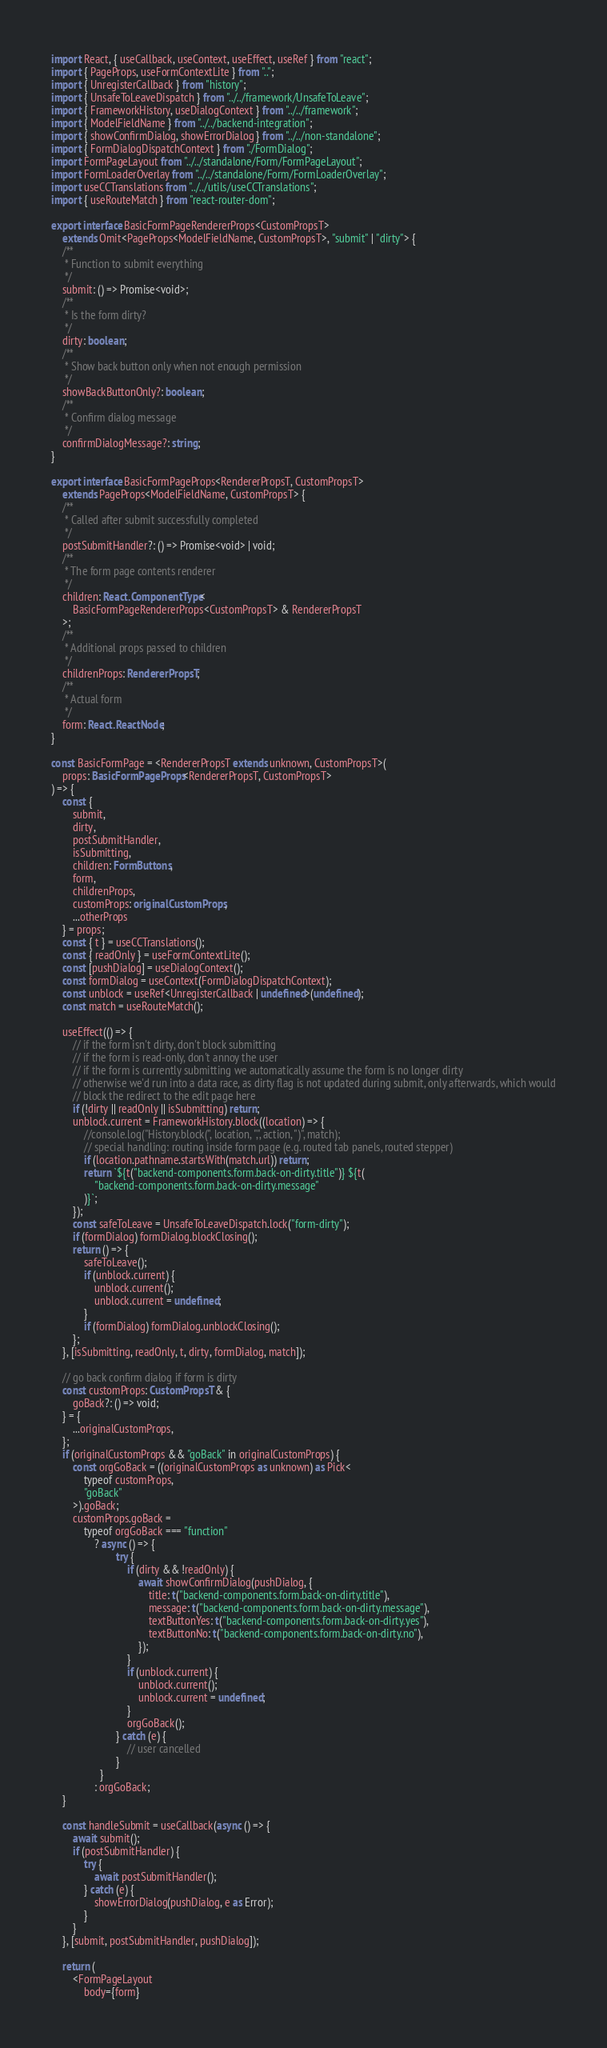<code> <loc_0><loc_0><loc_500><loc_500><_TypeScript_>import React, { useCallback, useContext, useEffect, useRef } from "react";
import { PageProps, useFormContextLite } from "..";
import { UnregisterCallback } from "history";
import { UnsafeToLeaveDispatch } from "../../framework/UnsafeToLeave";
import { FrameworkHistory, useDialogContext } from "../../framework";
import { ModelFieldName } from "../../backend-integration";
import { showConfirmDialog, showErrorDialog } from "../../non-standalone";
import { FormDialogDispatchContext } from "./FormDialog";
import FormPageLayout from "../../standalone/Form/FormPageLayout";
import FormLoaderOverlay from "../../standalone/Form/FormLoaderOverlay";
import useCCTranslations from "../../utils/useCCTranslations";
import { useRouteMatch } from "react-router-dom";

export interface BasicFormPageRendererProps<CustomPropsT>
	extends Omit<PageProps<ModelFieldName, CustomPropsT>, "submit" | "dirty"> {
	/**
	 * Function to submit everything
	 */
	submit: () => Promise<void>;
	/**
	 * Is the form dirty?
	 */
	dirty: boolean;
	/**
	 * Show back button only when not enough permission
	 */
	showBackButtonOnly?: boolean;
	/**
	 * Confirm dialog message
	 */
	confirmDialogMessage?: string;
}

export interface BasicFormPageProps<RendererPropsT, CustomPropsT>
	extends PageProps<ModelFieldName, CustomPropsT> {
	/**
	 * Called after submit successfully completed
	 */
	postSubmitHandler?: () => Promise<void> | void;
	/**
	 * The form page contents renderer
	 */
	children: React.ComponentType<
		BasicFormPageRendererProps<CustomPropsT> & RendererPropsT
	>;
	/**
	 * Additional props passed to children
	 */
	childrenProps: RendererPropsT;
	/**
	 * Actual form
	 */
	form: React.ReactNode;
}

const BasicFormPage = <RendererPropsT extends unknown, CustomPropsT>(
	props: BasicFormPageProps<RendererPropsT, CustomPropsT>
) => {
	const {
		submit,
		dirty,
		postSubmitHandler,
		isSubmitting,
		children: FormButtons,
		form,
		childrenProps,
		customProps: originalCustomProps,
		...otherProps
	} = props;
	const { t } = useCCTranslations();
	const { readOnly } = useFormContextLite();
	const [pushDialog] = useDialogContext();
	const formDialog = useContext(FormDialogDispatchContext);
	const unblock = useRef<UnregisterCallback | undefined>(undefined);
	const match = useRouteMatch();

	useEffect(() => {
		// if the form isn't dirty, don't block submitting
		// if the form is read-only, don't annoy the user
		// if the form is currently submitting we automatically assume the form is no longer dirty
		// otherwise we'd run into a data race, as dirty flag is not updated during submit, only afterwards, which would
		// block the redirect to the edit page here
		if (!dirty || readOnly || isSubmitting) return;
		unblock.current = FrameworkHistory.block((location) => {
			//console.log("History.block(", location, ",", action, ")", match);
			// special handling: routing inside form page (e.g. routed tab panels, routed stepper)
			if (location.pathname.startsWith(match.url)) return;
			return `${t("backend-components.form.back-on-dirty.title")} ${t(
				"backend-components.form.back-on-dirty.message"
			)}`;
		});
		const safeToLeave = UnsafeToLeaveDispatch.lock("form-dirty");
		if (formDialog) formDialog.blockClosing();
		return () => {
			safeToLeave();
			if (unblock.current) {
				unblock.current();
				unblock.current = undefined;
			}
			if (formDialog) formDialog.unblockClosing();
		};
	}, [isSubmitting, readOnly, t, dirty, formDialog, match]);

	// go back confirm dialog if form is dirty
	const customProps: CustomPropsT & {
		goBack?: () => void;
	} = {
		...originalCustomProps,
	};
	if (originalCustomProps && "goBack" in originalCustomProps) {
		const orgGoBack = ((originalCustomProps as unknown) as Pick<
			typeof customProps,
			"goBack"
		>).goBack;
		customProps.goBack =
			typeof orgGoBack === "function"
				? async () => {
						try {
							if (dirty && !readOnly) {
								await showConfirmDialog(pushDialog, {
									title: t("backend-components.form.back-on-dirty.title"),
									message: t("backend-components.form.back-on-dirty.message"),
									textButtonYes: t("backend-components.form.back-on-dirty.yes"),
									textButtonNo: t("backend-components.form.back-on-dirty.no"),
								});
							}
							if (unblock.current) {
								unblock.current();
								unblock.current = undefined;
							}
							orgGoBack();
						} catch (e) {
							// user cancelled
						}
				  }
				: orgGoBack;
	}

	const handleSubmit = useCallback(async () => {
		await submit();
		if (postSubmitHandler) {
			try {
				await postSubmitHandler();
			} catch (e) {
				showErrorDialog(pushDialog, e as Error);
			}
		}
	}, [submit, postSubmitHandler, pushDialog]);

	return (
		<FormPageLayout
			body={form}</code> 